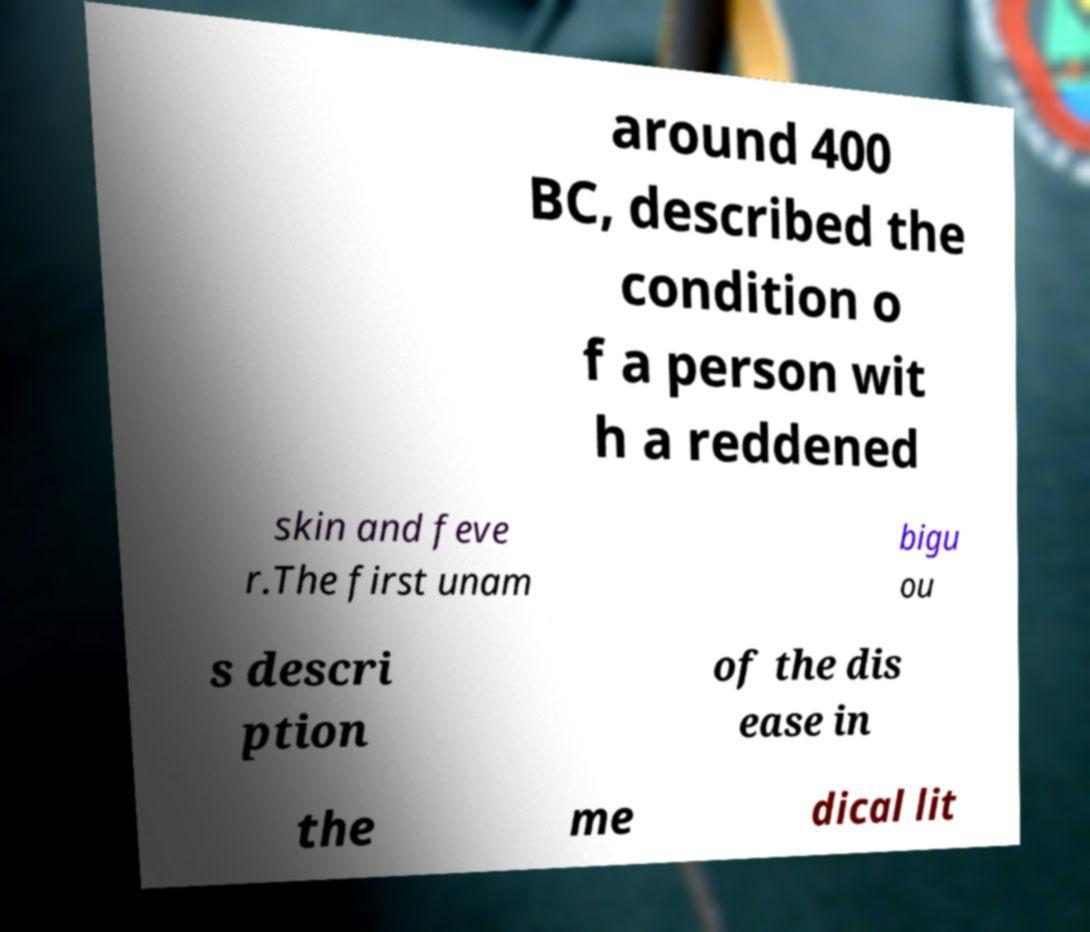Can you read and provide the text displayed in the image?This photo seems to have some interesting text. Can you extract and type it out for me? around 400 BC, described the condition o f a person wit h a reddened skin and feve r.The first unam bigu ou s descri ption of the dis ease in the me dical lit 